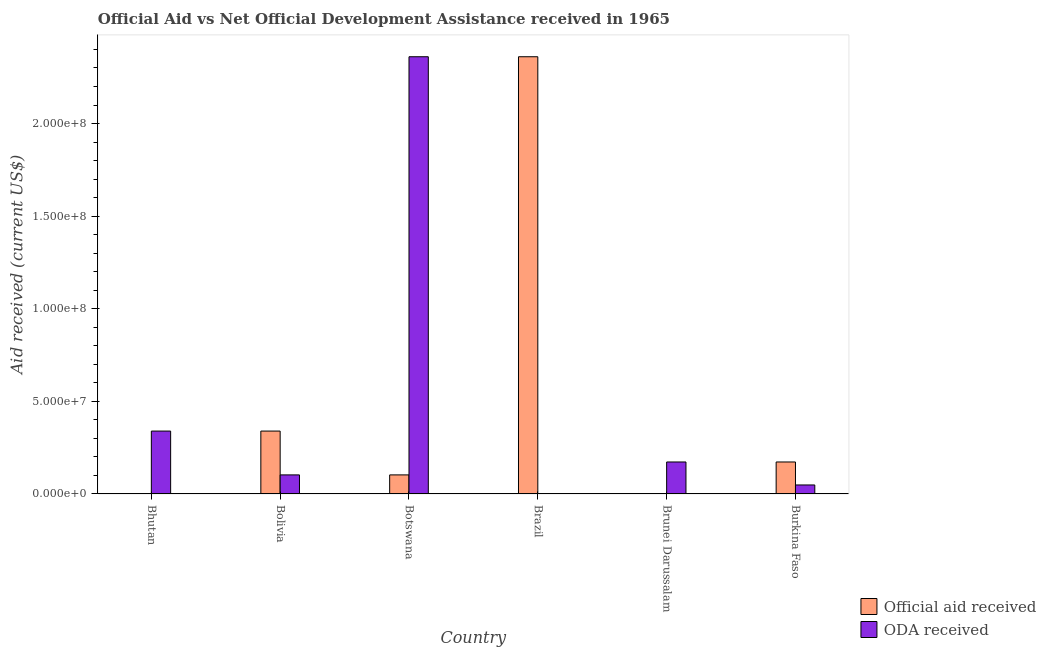How many different coloured bars are there?
Ensure brevity in your answer.  2. Are the number of bars on each tick of the X-axis equal?
Offer a terse response. Yes. How many bars are there on the 5th tick from the left?
Your response must be concise. 2. What is the label of the 3rd group of bars from the left?
Offer a very short reply. Botswana. What is the oda received in Bhutan?
Provide a succinct answer. 3.40e+07. Across all countries, what is the maximum official aid received?
Provide a short and direct response. 2.36e+08. Across all countries, what is the minimum official aid received?
Keep it short and to the point. 8.00e+04. In which country was the oda received maximum?
Your answer should be very brief. Botswana. In which country was the oda received minimum?
Your response must be concise. Brazil. What is the total oda received in the graph?
Provide a succinct answer. 3.03e+08. What is the difference between the oda received in Bhutan and that in Botswana?
Give a very brief answer. -2.02e+08. What is the difference between the oda received in Brazil and the official aid received in Botswana?
Make the answer very short. -1.02e+07. What is the average oda received per country?
Make the answer very short. 5.04e+07. What is the difference between the oda received and official aid received in Brazil?
Keep it short and to the point. -2.36e+08. What is the ratio of the oda received in Bolivia to that in Brunei Darussalam?
Give a very brief answer. 0.6. Is the official aid received in Bhutan less than that in Brunei Darussalam?
Offer a very short reply. No. Is the difference between the official aid received in Brazil and Brunei Darussalam greater than the difference between the oda received in Brazil and Brunei Darussalam?
Your answer should be very brief. Yes. What is the difference between the highest and the second highest official aid received?
Your response must be concise. 2.02e+08. What is the difference between the highest and the lowest official aid received?
Ensure brevity in your answer.  2.36e+08. In how many countries, is the official aid received greater than the average official aid received taken over all countries?
Offer a terse response. 1. What does the 2nd bar from the left in Bolivia represents?
Your answer should be compact. ODA received. What does the 1st bar from the right in Burkina Faso represents?
Offer a terse response. ODA received. How many bars are there?
Ensure brevity in your answer.  12. What is the difference between two consecutive major ticks on the Y-axis?
Keep it short and to the point. 5.00e+07. Are the values on the major ticks of Y-axis written in scientific E-notation?
Offer a terse response. Yes. How are the legend labels stacked?
Your response must be concise. Vertical. What is the title of the graph?
Provide a short and direct response. Official Aid vs Net Official Development Assistance received in 1965 . Does "Enforce a contract" appear as one of the legend labels in the graph?
Provide a short and direct response. No. What is the label or title of the X-axis?
Your answer should be compact. Country. What is the label or title of the Y-axis?
Keep it short and to the point. Aid received (current US$). What is the Aid received (current US$) of Official aid received in Bhutan?
Your response must be concise. 1.60e+05. What is the Aid received (current US$) in ODA received in Bhutan?
Give a very brief answer. 3.40e+07. What is the Aid received (current US$) in Official aid received in Bolivia?
Provide a short and direct response. 3.40e+07. What is the Aid received (current US$) of ODA received in Bolivia?
Provide a succinct answer. 1.03e+07. What is the Aid received (current US$) in Official aid received in Botswana?
Your answer should be very brief. 1.03e+07. What is the Aid received (current US$) of ODA received in Botswana?
Your response must be concise. 2.36e+08. What is the Aid received (current US$) in Official aid received in Brazil?
Your answer should be very brief. 2.36e+08. What is the Aid received (current US$) in ODA received in Brazil?
Ensure brevity in your answer.  8.00e+04. What is the Aid received (current US$) in Official aid received in Brunei Darussalam?
Provide a succinct answer. 8.00e+04. What is the Aid received (current US$) of ODA received in Brunei Darussalam?
Make the answer very short. 1.73e+07. What is the Aid received (current US$) in Official aid received in Burkina Faso?
Your answer should be compact. 1.73e+07. What is the Aid received (current US$) of ODA received in Burkina Faso?
Keep it short and to the point. 4.86e+06. Across all countries, what is the maximum Aid received (current US$) of Official aid received?
Give a very brief answer. 2.36e+08. Across all countries, what is the maximum Aid received (current US$) of ODA received?
Ensure brevity in your answer.  2.36e+08. Across all countries, what is the minimum Aid received (current US$) of Official aid received?
Your answer should be very brief. 8.00e+04. What is the total Aid received (current US$) of Official aid received in the graph?
Your answer should be compact. 2.98e+08. What is the total Aid received (current US$) of ODA received in the graph?
Make the answer very short. 3.03e+08. What is the difference between the Aid received (current US$) of Official aid received in Bhutan and that in Bolivia?
Provide a succinct answer. -3.38e+07. What is the difference between the Aid received (current US$) in ODA received in Bhutan and that in Bolivia?
Offer a very short reply. 2.37e+07. What is the difference between the Aid received (current US$) of Official aid received in Bhutan and that in Botswana?
Provide a succinct answer. -1.01e+07. What is the difference between the Aid received (current US$) of ODA received in Bhutan and that in Botswana?
Your answer should be compact. -2.02e+08. What is the difference between the Aid received (current US$) in Official aid received in Bhutan and that in Brazil?
Your answer should be very brief. -2.36e+08. What is the difference between the Aid received (current US$) in ODA received in Bhutan and that in Brazil?
Your response must be concise. 3.39e+07. What is the difference between the Aid received (current US$) in ODA received in Bhutan and that in Brunei Darussalam?
Keep it short and to the point. 1.67e+07. What is the difference between the Aid received (current US$) of Official aid received in Bhutan and that in Burkina Faso?
Your answer should be compact. -1.71e+07. What is the difference between the Aid received (current US$) of ODA received in Bhutan and that in Burkina Faso?
Ensure brevity in your answer.  2.91e+07. What is the difference between the Aid received (current US$) in Official aid received in Bolivia and that in Botswana?
Keep it short and to the point. 2.37e+07. What is the difference between the Aid received (current US$) of ODA received in Bolivia and that in Botswana?
Give a very brief answer. -2.26e+08. What is the difference between the Aid received (current US$) in Official aid received in Bolivia and that in Brazil?
Your response must be concise. -2.02e+08. What is the difference between the Aid received (current US$) of ODA received in Bolivia and that in Brazil?
Make the answer very short. 1.02e+07. What is the difference between the Aid received (current US$) of Official aid received in Bolivia and that in Brunei Darussalam?
Keep it short and to the point. 3.39e+07. What is the difference between the Aid received (current US$) in ODA received in Bolivia and that in Brunei Darussalam?
Ensure brevity in your answer.  -6.97e+06. What is the difference between the Aid received (current US$) in Official aid received in Bolivia and that in Burkina Faso?
Provide a short and direct response. 1.67e+07. What is the difference between the Aid received (current US$) in ODA received in Bolivia and that in Burkina Faso?
Your answer should be compact. 5.44e+06. What is the difference between the Aid received (current US$) in Official aid received in Botswana and that in Brazil?
Your answer should be very brief. -2.26e+08. What is the difference between the Aid received (current US$) of ODA received in Botswana and that in Brazil?
Keep it short and to the point. 2.36e+08. What is the difference between the Aid received (current US$) in Official aid received in Botswana and that in Brunei Darussalam?
Provide a succinct answer. 1.02e+07. What is the difference between the Aid received (current US$) in ODA received in Botswana and that in Brunei Darussalam?
Provide a succinct answer. 2.19e+08. What is the difference between the Aid received (current US$) of Official aid received in Botswana and that in Burkina Faso?
Ensure brevity in your answer.  -6.97e+06. What is the difference between the Aid received (current US$) of ODA received in Botswana and that in Burkina Faso?
Provide a succinct answer. 2.31e+08. What is the difference between the Aid received (current US$) of Official aid received in Brazil and that in Brunei Darussalam?
Make the answer very short. 2.36e+08. What is the difference between the Aid received (current US$) of ODA received in Brazil and that in Brunei Darussalam?
Your answer should be compact. -1.72e+07. What is the difference between the Aid received (current US$) in Official aid received in Brazil and that in Burkina Faso?
Keep it short and to the point. 2.19e+08. What is the difference between the Aid received (current US$) in ODA received in Brazil and that in Burkina Faso?
Provide a succinct answer. -4.78e+06. What is the difference between the Aid received (current US$) of Official aid received in Brunei Darussalam and that in Burkina Faso?
Your answer should be compact. -1.72e+07. What is the difference between the Aid received (current US$) in ODA received in Brunei Darussalam and that in Burkina Faso?
Give a very brief answer. 1.24e+07. What is the difference between the Aid received (current US$) in Official aid received in Bhutan and the Aid received (current US$) in ODA received in Bolivia?
Provide a short and direct response. -1.01e+07. What is the difference between the Aid received (current US$) of Official aid received in Bhutan and the Aid received (current US$) of ODA received in Botswana?
Provide a short and direct response. -2.36e+08. What is the difference between the Aid received (current US$) in Official aid received in Bhutan and the Aid received (current US$) in ODA received in Brunei Darussalam?
Your response must be concise. -1.71e+07. What is the difference between the Aid received (current US$) in Official aid received in Bhutan and the Aid received (current US$) in ODA received in Burkina Faso?
Give a very brief answer. -4.70e+06. What is the difference between the Aid received (current US$) of Official aid received in Bolivia and the Aid received (current US$) of ODA received in Botswana?
Provide a short and direct response. -2.02e+08. What is the difference between the Aid received (current US$) in Official aid received in Bolivia and the Aid received (current US$) in ODA received in Brazil?
Provide a short and direct response. 3.39e+07. What is the difference between the Aid received (current US$) of Official aid received in Bolivia and the Aid received (current US$) of ODA received in Brunei Darussalam?
Give a very brief answer. 1.67e+07. What is the difference between the Aid received (current US$) in Official aid received in Bolivia and the Aid received (current US$) in ODA received in Burkina Faso?
Ensure brevity in your answer.  2.91e+07. What is the difference between the Aid received (current US$) in Official aid received in Botswana and the Aid received (current US$) in ODA received in Brazil?
Your answer should be compact. 1.02e+07. What is the difference between the Aid received (current US$) of Official aid received in Botswana and the Aid received (current US$) of ODA received in Brunei Darussalam?
Keep it short and to the point. -6.97e+06. What is the difference between the Aid received (current US$) of Official aid received in Botswana and the Aid received (current US$) of ODA received in Burkina Faso?
Your answer should be compact. 5.44e+06. What is the difference between the Aid received (current US$) of Official aid received in Brazil and the Aid received (current US$) of ODA received in Brunei Darussalam?
Make the answer very short. 2.19e+08. What is the difference between the Aid received (current US$) of Official aid received in Brazil and the Aid received (current US$) of ODA received in Burkina Faso?
Your response must be concise. 2.31e+08. What is the difference between the Aid received (current US$) of Official aid received in Brunei Darussalam and the Aid received (current US$) of ODA received in Burkina Faso?
Provide a succinct answer. -4.78e+06. What is the average Aid received (current US$) in Official aid received per country?
Your answer should be very brief. 4.96e+07. What is the average Aid received (current US$) in ODA received per country?
Give a very brief answer. 5.04e+07. What is the difference between the Aid received (current US$) in Official aid received and Aid received (current US$) in ODA received in Bhutan?
Keep it short and to the point. -3.38e+07. What is the difference between the Aid received (current US$) in Official aid received and Aid received (current US$) in ODA received in Bolivia?
Provide a succinct answer. 2.37e+07. What is the difference between the Aid received (current US$) in Official aid received and Aid received (current US$) in ODA received in Botswana?
Your answer should be very brief. -2.26e+08. What is the difference between the Aid received (current US$) of Official aid received and Aid received (current US$) of ODA received in Brazil?
Your answer should be very brief. 2.36e+08. What is the difference between the Aid received (current US$) of Official aid received and Aid received (current US$) of ODA received in Brunei Darussalam?
Your response must be concise. -1.72e+07. What is the difference between the Aid received (current US$) of Official aid received and Aid received (current US$) of ODA received in Burkina Faso?
Your answer should be very brief. 1.24e+07. What is the ratio of the Aid received (current US$) in Official aid received in Bhutan to that in Bolivia?
Make the answer very short. 0. What is the ratio of the Aid received (current US$) in ODA received in Bhutan to that in Bolivia?
Provide a succinct answer. 3.3. What is the ratio of the Aid received (current US$) of Official aid received in Bhutan to that in Botswana?
Give a very brief answer. 0.02. What is the ratio of the Aid received (current US$) in ODA received in Bhutan to that in Botswana?
Offer a terse response. 0.14. What is the ratio of the Aid received (current US$) of Official aid received in Bhutan to that in Brazil?
Your answer should be very brief. 0. What is the ratio of the Aid received (current US$) of ODA received in Bhutan to that in Brazil?
Your answer should be very brief. 424.5. What is the ratio of the Aid received (current US$) in Official aid received in Bhutan to that in Brunei Darussalam?
Ensure brevity in your answer.  2. What is the ratio of the Aid received (current US$) in ODA received in Bhutan to that in Brunei Darussalam?
Offer a very short reply. 1.97. What is the ratio of the Aid received (current US$) in Official aid received in Bhutan to that in Burkina Faso?
Provide a succinct answer. 0.01. What is the ratio of the Aid received (current US$) of ODA received in Bhutan to that in Burkina Faso?
Give a very brief answer. 6.99. What is the ratio of the Aid received (current US$) in Official aid received in Bolivia to that in Botswana?
Your answer should be compact. 3.3. What is the ratio of the Aid received (current US$) in ODA received in Bolivia to that in Botswana?
Your answer should be very brief. 0.04. What is the ratio of the Aid received (current US$) in Official aid received in Bolivia to that in Brazil?
Offer a terse response. 0.14. What is the ratio of the Aid received (current US$) of ODA received in Bolivia to that in Brazil?
Provide a short and direct response. 128.75. What is the ratio of the Aid received (current US$) of Official aid received in Bolivia to that in Brunei Darussalam?
Your response must be concise. 424.5. What is the ratio of the Aid received (current US$) in ODA received in Bolivia to that in Brunei Darussalam?
Give a very brief answer. 0.6. What is the ratio of the Aid received (current US$) in Official aid received in Bolivia to that in Burkina Faso?
Keep it short and to the point. 1.97. What is the ratio of the Aid received (current US$) of ODA received in Bolivia to that in Burkina Faso?
Give a very brief answer. 2.12. What is the ratio of the Aid received (current US$) in Official aid received in Botswana to that in Brazil?
Offer a terse response. 0.04. What is the ratio of the Aid received (current US$) in ODA received in Botswana to that in Brazil?
Ensure brevity in your answer.  2950.88. What is the ratio of the Aid received (current US$) in Official aid received in Botswana to that in Brunei Darussalam?
Provide a succinct answer. 128.75. What is the ratio of the Aid received (current US$) in ODA received in Botswana to that in Brunei Darussalam?
Offer a very short reply. 13.67. What is the ratio of the Aid received (current US$) in Official aid received in Botswana to that in Burkina Faso?
Your answer should be compact. 0.6. What is the ratio of the Aid received (current US$) of ODA received in Botswana to that in Burkina Faso?
Your answer should be very brief. 48.57. What is the ratio of the Aid received (current US$) in Official aid received in Brazil to that in Brunei Darussalam?
Ensure brevity in your answer.  2950.88. What is the ratio of the Aid received (current US$) in ODA received in Brazil to that in Brunei Darussalam?
Give a very brief answer. 0. What is the ratio of the Aid received (current US$) in Official aid received in Brazil to that in Burkina Faso?
Your response must be concise. 13.67. What is the ratio of the Aid received (current US$) in ODA received in Brazil to that in Burkina Faso?
Give a very brief answer. 0.02. What is the ratio of the Aid received (current US$) in Official aid received in Brunei Darussalam to that in Burkina Faso?
Offer a very short reply. 0. What is the ratio of the Aid received (current US$) of ODA received in Brunei Darussalam to that in Burkina Faso?
Keep it short and to the point. 3.55. What is the difference between the highest and the second highest Aid received (current US$) of Official aid received?
Your answer should be very brief. 2.02e+08. What is the difference between the highest and the second highest Aid received (current US$) in ODA received?
Give a very brief answer. 2.02e+08. What is the difference between the highest and the lowest Aid received (current US$) in Official aid received?
Offer a terse response. 2.36e+08. What is the difference between the highest and the lowest Aid received (current US$) in ODA received?
Make the answer very short. 2.36e+08. 